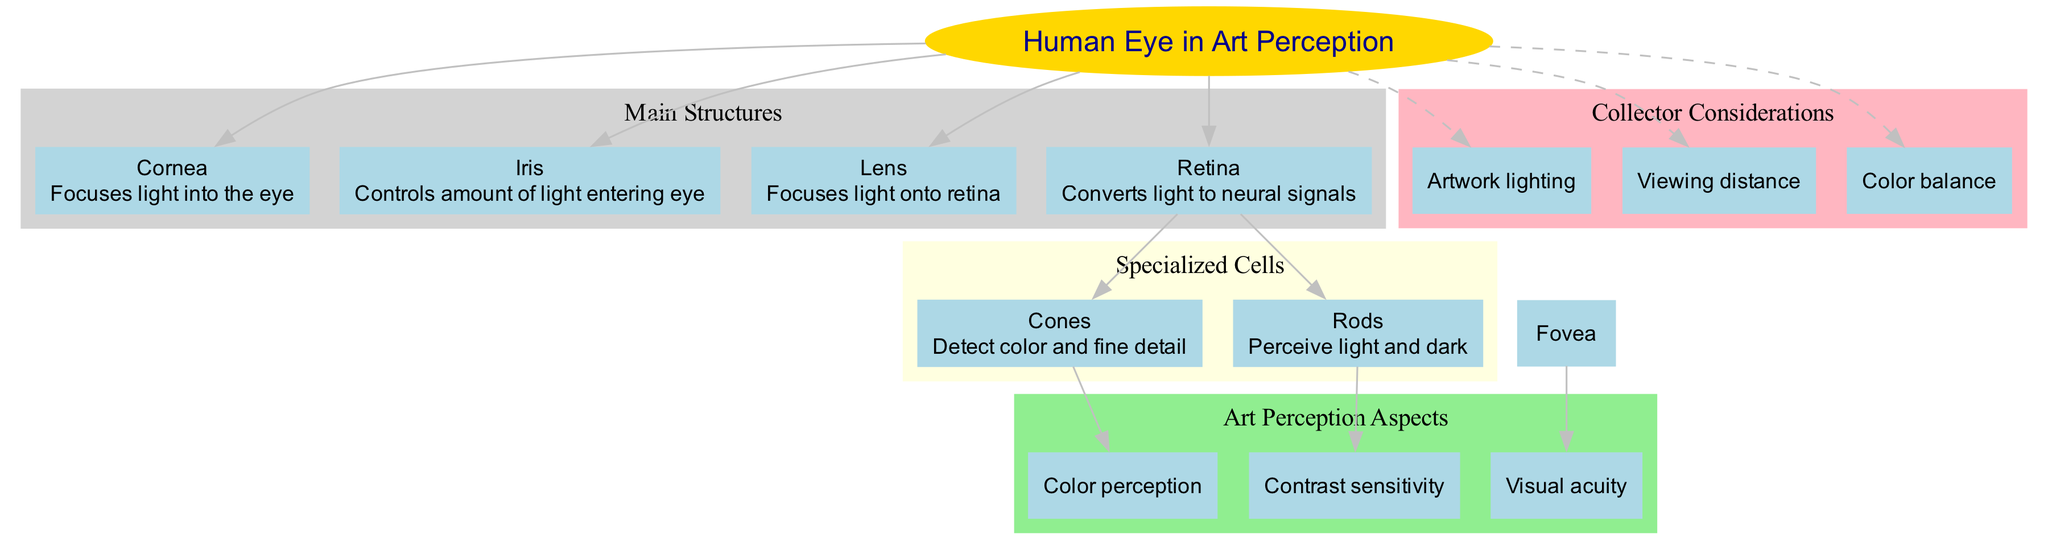What is the main function of the Cornea? According to the diagram, the Cornea focuses light into the eye. This is a basic descriptive aspect of the diagram where the function is directly associated with the structure named Cornea.
Answer: Focuses light into the eye How many main structures are depicted in the diagram? The diagram lists four main structures: Cornea, Iris, Lens, and Retina. By counting these nodes, we determine the total number of main structures is four.
Answer: 4 Which specialized cell is responsible for detecting color? The diagram states that Cones are responsible for detecting color, making it necessary to locate the node for specialized cells and reference their functions.
Answer: Cones What connects the Retina to Color perception? The diagram illustrates that Color perception is related to the specialized cells called Cones, as indicated by the edge connecting these two nodes in the Art Perception Aspects section.
Answer: Cones How does the Iris contribute to art perception? The Iris controls the amount of light entering the eye, which indirectly affects art perception by regulating visibility and clarity of artworks, showing the relationship between the structure and its role in viewing art.
Answer: Controls amount of light entering eye Which aspect of art perception is linked to the function of Rods? The diagram links Contrast sensitivity to the function of Rods, as the edge indicates that Rods are directly associated with perceiving light and dark, which is essential for contrast sensitivity.
Answer: Contrast sensitivity What is one consideration for collectors regarding viewing artworks? The diagram lists several collector considerations, and one of them is Artwork lighting, which highlights its importance in the viewing experience of artworks.
Answer: Artwork lighting Name a structure that focuses light onto the retina. The diagram denotes the Lens as the structure that focuses light onto the retina, making it clear through the node's description that this is the function assigned to the Lens.
Answer: Lens 